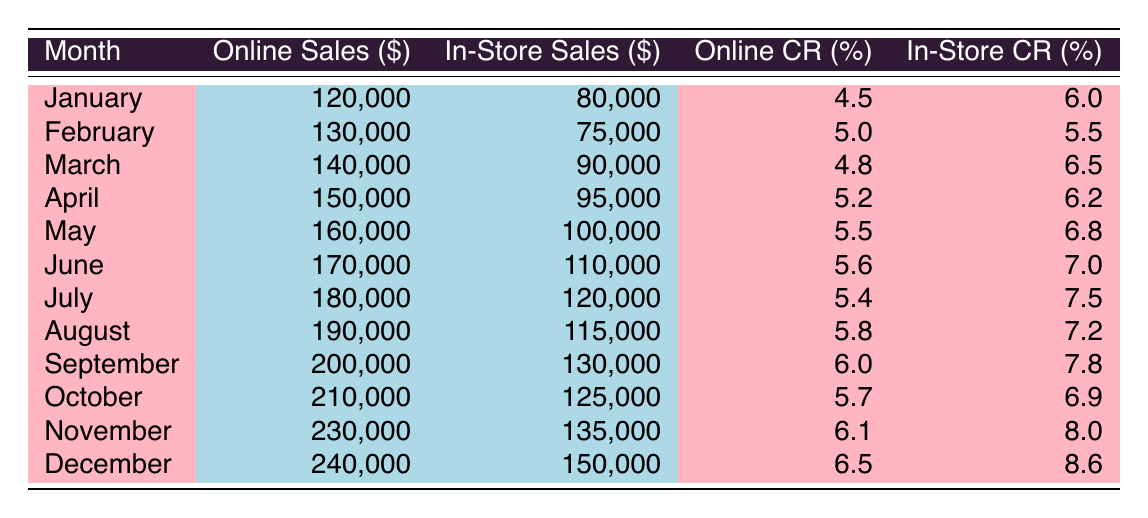What was the total online sales for December? The table shows online sales for December, which is directly listed as 240,000.
Answer: 240,000 Which month had the highest in-store sales? By examining the values in the in-store sales column, November shows the highest in-store sales at 135,000.
Answer: November What is the difference in online sales between January and June? Online sales in January is 120,000 and in June is 170,000. The difference is calculated as 170,000 - 120,000 = 50,000.
Answer: 50,000 What was the average conversion rate for online purchases over the year? The conversion rates for online purchases are: 4.5, 5.0, 4.8, 5.2, 5.5, 5.6, 5.4, 5.8, 6.0, 5.7, 6.1, and 6.5. Adding these values gives 66.7, and dividing by 12 (months) results in an average of 5.56.
Answer: 5.56 Did the conversion rate for in-store purchases increase from January to December? Looking at the conversion rates for in-store purchases, January has a rate of 6.0 and December shows 8.6. Since 8.6 is greater than 6.0, the conversion rate did indeed increase.
Answer: Yes In which month were online sales the closest to in-store sales? By analyzing the rows, comparing online and in-store sales, we find that in July, online sales (180,000) minus in-store sales (120,000) gives a difference of 60,000, the smallest difference across all months.
Answer: July Which month had a greater conversion rate for in-store purchases than the online rate? In examining the table, July's in-store conversion rate is 7.5, which is higher than the online conversion rate of 5.4, confirming it was one such month.
Answer: July What was the total in-store sales for the first half of the year (January to June)? The in-store sales from January to June are 80,000, 75,000, 90,000, 95,000, 100,000, and 110,000. Adding these amounts gives a total of 80,000 + 75,000 + 90,000 + 95,000 + 100,000 + 110,000 = 550,000.
Answer: 550,000 Was the conversion rate for in-store purchases in September lower than August? The conversion rate for in-store purchases in August is 7.2, and in September it is 7.8. Since 7.8 is greater than 7.2, September's conversion rate is not lower than August's.
Answer: No 